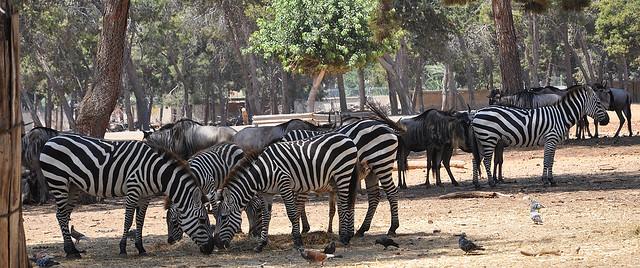Are these animals in the wild?
Keep it brief. No. Is it winter?
Concise answer only. No. Which animals are this?
Keep it brief. Zebras. Are all the zebras hugging?
Keep it brief. No. 